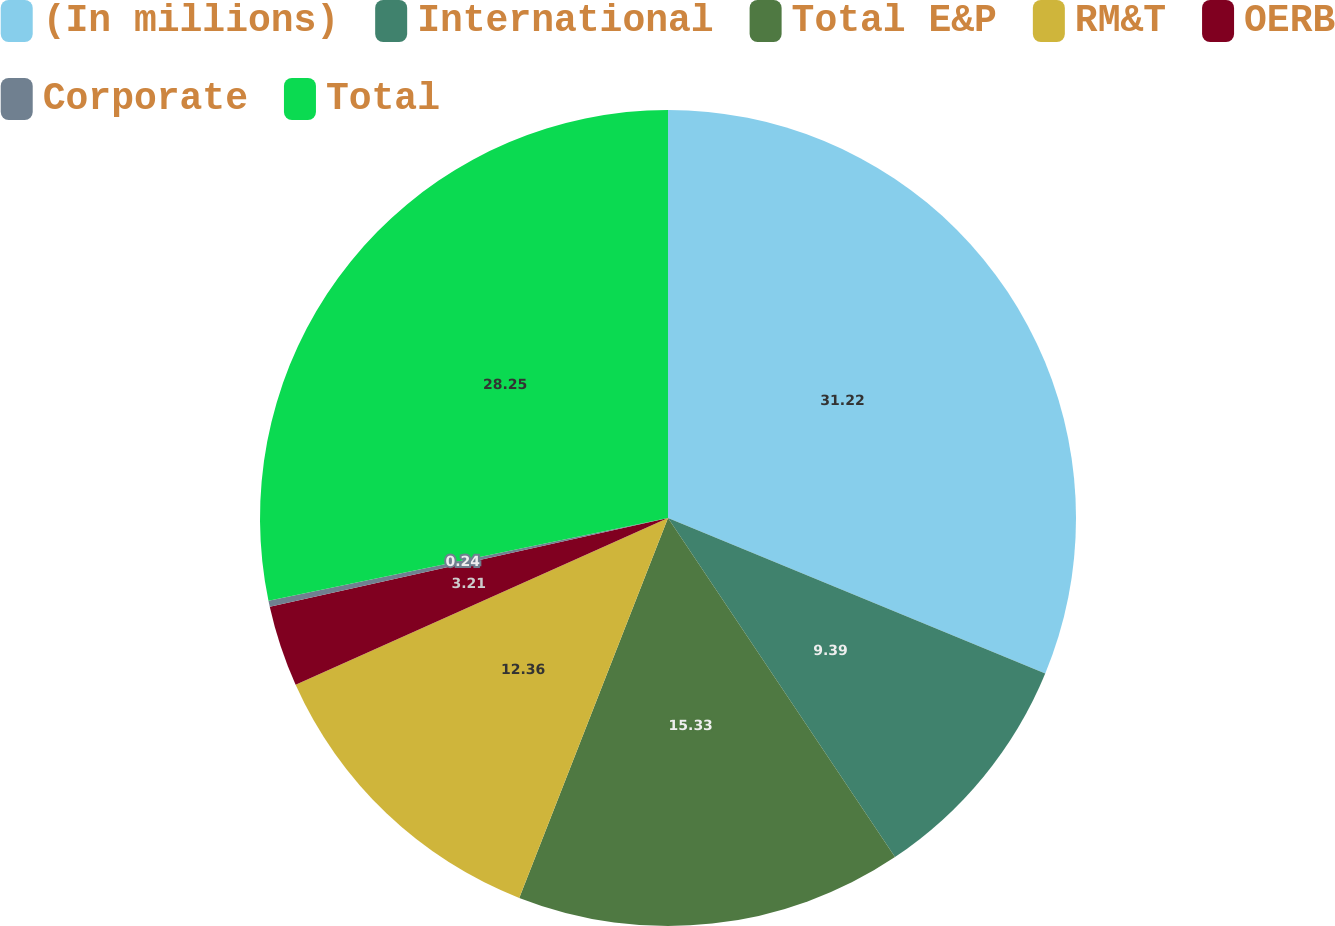Convert chart. <chart><loc_0><loc_0><loc_500><loc_500><pie_chart><fcel>(In millions)<fcel>International<fcel>Total E&P<fcel>RM&T<fcel>OERB<fcel>Corporate<fcel>Total<nl><fcel>31.22%<fcel>9.39%<fcel>15.33%<fcel>12.36%<fcel>3.21%<fcel>0.24%<fcel>28.25%<nl></chart> 